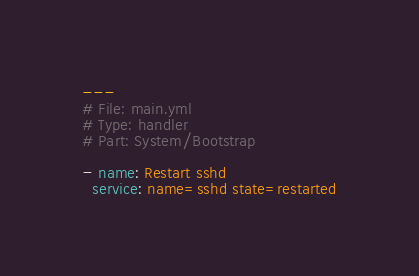Convert code to text. <code><loc_0><loc_0><loc_500><loc_500><_YAML_>---
# File: main.yml
# Type: handler
# Part: System/Bootstrap

- name: Restart sshd
  service: name=sshd state=restarted
</code> 